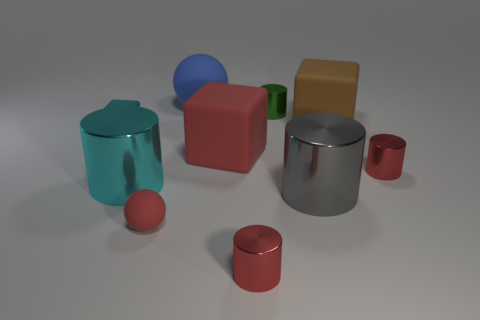Subtract all cyan cylinders. How many cylinders are left? 4 Subtract all cyan cylinders. How many cylinders are left? 4 Subtract all yellow cylinders. Subtract all purple balls. How many cylinders are left? 5 Subtract all spheres. How many objects are left? 8 Subtract 0 yellow cubes. How many objects are left? 10 Subtract all green objects. Subtract all big gray cylinders. How many objects are left? 8 Add 5 big brown rubber objects. How many big brown rubber objects are left? 6 Add 6 small yellow cylinders. How many small yellow cylinders exist? 6 